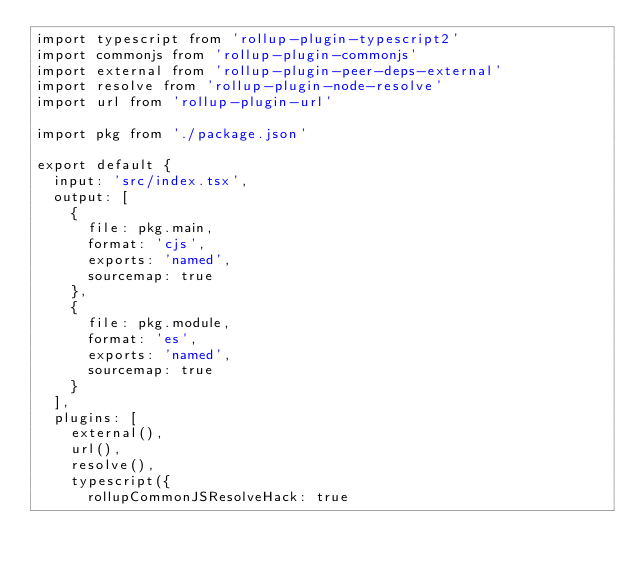<code> <loc_0><loc_0><loc_500><loc_500><_JavaScript_>import typescript from 'rollup-plugin-typescript2'
import commonjs from 'rollup-plugin-commonjs'
import external from 'rollup-plugin-peer-deps-external'
import resolve from 'rollup-plugin-node-resolve'
import url from 'rollup-plugin-url'

import pkg from './package.json'

export default {
  input: 'src/index.tsx',
  output: [
    {
      file: pkg.main,
      format: 'cjs',
      exports: 'named',
      sourcemap: true
    },
    {
      file: pkg.module,
      format: 'es',
      exports: 'named',
      sourcemap: true
    }
  ],
  plugins: [
    external(),
    url(),
    resolve(),
    typescript({
      rollupCommonJSResolveHack: true</code> 